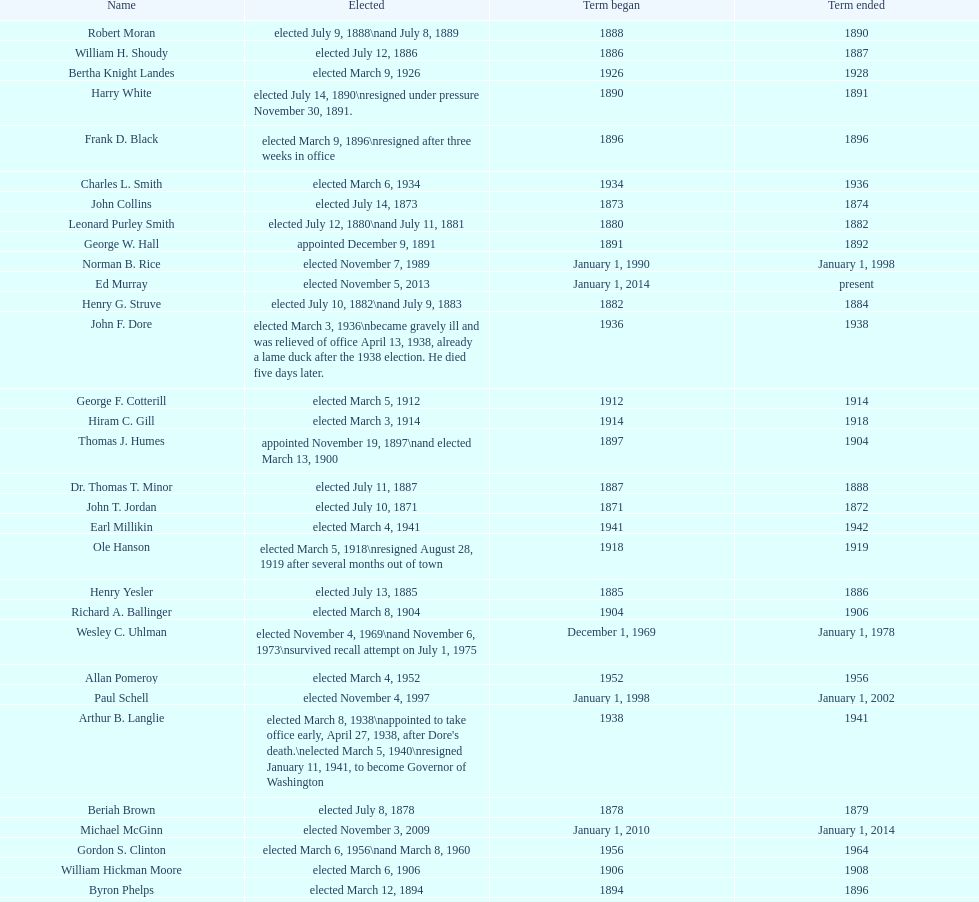How many days did robert moran serve? 365. Help me parse the entirety of this table. {'header': ['Name', 'Elected', 'Term began', 'Term ended'], 'rows': [['Robert Moran', 'elected July 9, 1888\\nand July 8, 1889', '1888', '1890'], ['William H. Shoudy', 'elected July 12, 1886', '1886', '1887'], ['Bertha Knight Landes', 'elected March 9, 1926', '1926', '1928'], ['Harry White', 'elected July 14, 1890\\nresigned under pressure November 30, 1891.', '1890', '1891'], ['Frank D. Black', 'elected March 9, 1896\\nresigned after three weeks in office', '1896', '1896'], ['Charles L. Smith', 'elected March 6, 1934', '1934', '1936'], ['John Collins', 'elected July 14, 1873', '1873', '1874'], ['Leonard Purley Smith', 'elected July 12, 1880\\nand July 11, 1881', '1880', '1882'], ['George W. Hall', 'appointed December 9, 1891', '1891', '1892'], ['Norman B. Rice', 'elected November 7, 1989', 'January 1, 1990', 'January 1, 1998'], ['Ed Murray', 'elected November 5, 2013', 'January 1, 2014', 'present'], ['Henry G. Struve', 'elected July 10, 1882\\nand July 9, 1883', '1882', '1884'], ['John F. Dore', 'elected March 3, 1936\\nbecame gravely ill and was relieved of office April 13, 1938, already a lame duck after the 1938 election. He died five days later.', '1936', '1938'], ['George F. Cotterill', 'elected March 5, 1912', '1912', '1914'], ['Hiram C. Gill', 'elected March 3, 1914', '1914', '1918'], ['Thomas J. Humes', 'appointed November 19, 1897\\nand elected March 13, 1900', '1897', '1904'], ['Dr. Thomas T. Minor', 'elected July 11, 1887', '1887', '1888'], ['John T. Jordan', 'elected July 10, 1871', '1871', '1872'], ['Earl Millikin', 'elected March 4, 1941', '1941', '1942'], ['Ole Hanson', 'elected March 5, 1918\\nresigned August 28, 1919 after several months out of town', '1918', '1919'], ['Henry Yesler', 'elected July 13, 1885', '1885', '1886'], ['Richard A. Ballinger', 'elected March 8, 1904', '1904', '1906'], ['Wesley C. Uhlman', 'elected November 4, 1969\\nand November 6, 1973\\nsurvived recall attempt on July 1, 1975', 'December 1, 1969', 'January 1, 1978'], ['Allan Pomeroy', 'elected March 4, 1952', '1952', '1956'], ['Paul Schell', 'elected November 4, 1997', 'January 1, 1998', 'January 1, 2002'], ['Arthur B. Langlie', "elected March 8, 1938\\nappointed to take office early, April 27, 1938, after Dore's death.\\nelected March 5, 1940\\nresigned January 11, 1941, to become Governor of Washington", '1938', '1941'], ['Beriah Brown', 'elected July 8, 1878', '1878', '1879'], ['Michael McGinn', 'elected November 3, 2009', 'January 1, 2010', 'January 1, 2014'], ['Gordon S. Clinton', 'elected March 6, 1956\\nand March 8, 1960', '1956', '1964'], ['William Hickman Moore', 'elected March 6, 1906', '1906', '1908'], ['Byron Phelps', 'elected March 12, 1894', '1894', '1896'], ['Henry Yesler', 'elected July 13, 1874', '1874', '1875'], ['Bailey Gatzert', 'elected August 2, 1875', '1875', '1876'], ['Floyd C. Miller', 'appointed March 23, 1969', '1969', '1969'], ['Moses R. Maddocks', 'Elected', '1873', '1873'], ['Robert H. Harlin', 'appointed July 14, 1931', '1931', '1932'], ['John Leary', 'elected July 14, 1884', '1884', '1885'], ['John T. Jordan', 'appointed', '1873', '1873'], ['Edwin J. Brown', 'elected May 2, 1922\\nand March 4, 1924', '1922', '1926'], ['C. B. Fitzgerald', 'appointed August 28, 1919', '1919', '1920'], ['Henry A. Atkins', 'appointed December 2, 1869\\nelected July 11, 1870', '1869', '1871'], ['George W. Dilling', 'appointed February 10, 1911[citation needed]', '1912', ''], ['Orange Jacobs', 'elected July 14, 1879', '1879', '1880'], ['Frank E. Edwards', 'elected March 6, 1928\\nand March 4, 1930\\nrecalled July 13, 1931', '1928', '1931'], ['Hugh M. Caldwell', 'elected March 2, 1920', '1920', '1922'], ['Gregory J. Nickels', 'elected November 6, 2001\\nand November 8, 2005', 'January 1, 2002', 'January 1, 2010'], ['Hiram C. Gill', 'elected March 8, 1910\\nrecalled February 9, 1911', '1910', '1911'], ['John F. Dore', 'elected March 8, 1932', '1932', '1934'], ["James d'Orma Braman", 'elected March 10, 1964\\nresigned March 23, 1969, to accept an appointment as an Assistant Secretary in the Department of Transportation in the Nixon administration.', '1964', '1969'], ['Gideon A. Weed', 'elected July 10, 1876\\nand July 9, 1877', '1876', '1878'], ['Charles Royer', 'elected November 8, 1977, November 3, 1981, and November 5, 1985', 'January 1, 1978', 'January 1, 1990'], ['James T. Ronald', 'elected March 8, 1892', '1892', '1894'], ['William F. Devin', 'elected March 3, 1942, March 7, 1944, March 5, 1946, and March 2, 1948', '1942', '1952'], ['W. D. Wood', 'appointed April 6, 1896\\nresigned July 1897', '1896', '1897'], ['John E. Carroll', 'appointed January 27, 1941', '1941', '1941'], ['John F. Miller', 'elected March 3, 1908', '1908', '1910'], ['Corliss P. Stone', 'elected July 8, 1872\\nabandoned office: left for San Francisco February 23, 1873 after allegedly embezzling $15,000', '1872', '1873']]} 